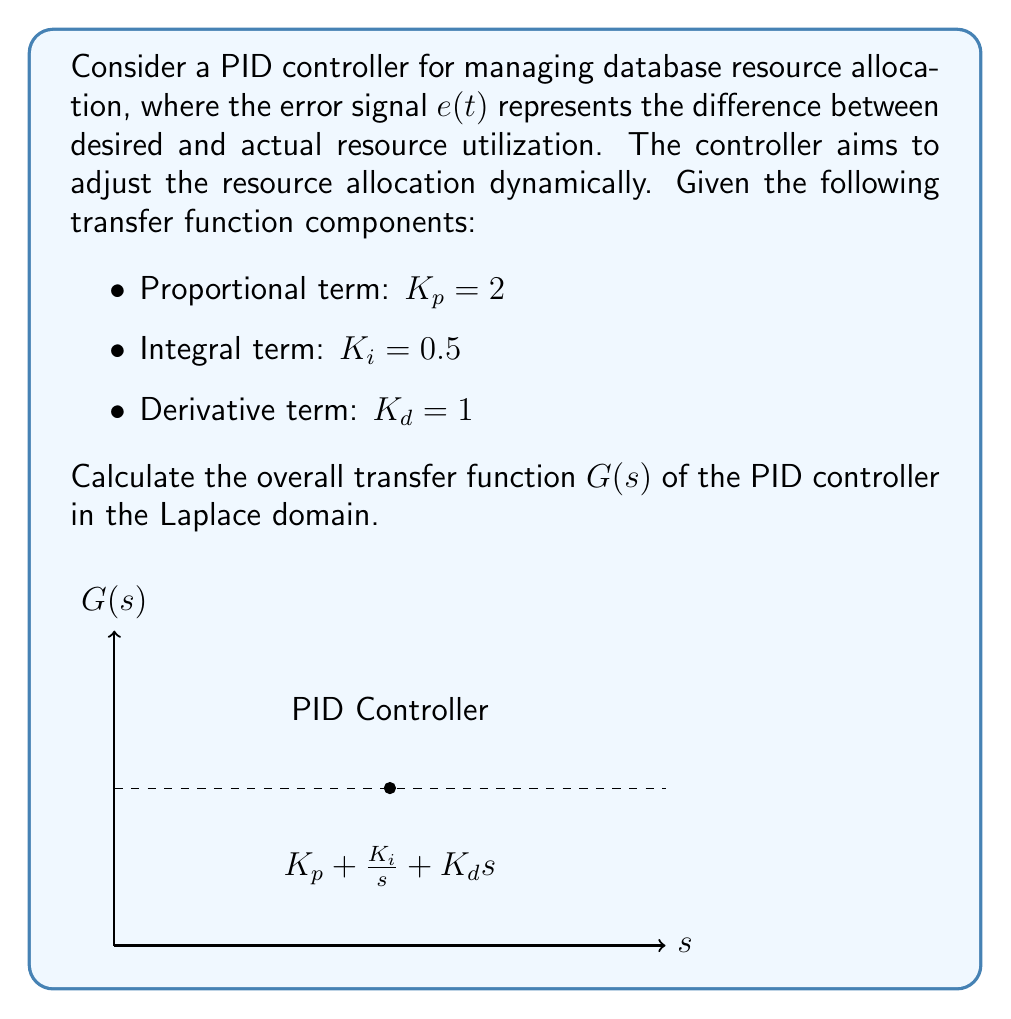Help me with this question. To calculate the transfer function of the PID controller, we need to combine the three components: proportional, integral, and derivative terms. Let's follow these steps:

1. Recall the general form of a PID controller in the time domain:
   $$u(t) = K_p e(t) + K_i \int_0^t e(\tau) d\tau + K_d \frac{de(t)}{dt}$$

2. Transform this equation to the Laplace domain:
   $$U(s) = K_p E(s) + K_i \frac{E(s)}{s} + K_d s E(s)$$

3. The transfer function $G(s)$ is defined as the ratio of output to input in the Laplace domain:
   $$G(s) = \frac{U(s)}{E(s)} = K_p + \frac{K_i}{s} + K_d s$$

4. Substitute the given values:
   $$G(s) = 2 + \frac{0.5}{s} + 1s$$

5. To express this as a single fraction, find a common denominator:
   $$G(s) = \frac{2s}{s} + \frac{0.5}{s} + \frac{s^2}{s}$$

6. Combine the terms:
   $$G(s) = \frac{s^2 + 2s + 0.5}{s}$$

This is the final transfer function of the PID controller for managing database resource allocation.
Answer: $$G(s) = \frac{s^2 + 2s + 0.5}{s}$$ 